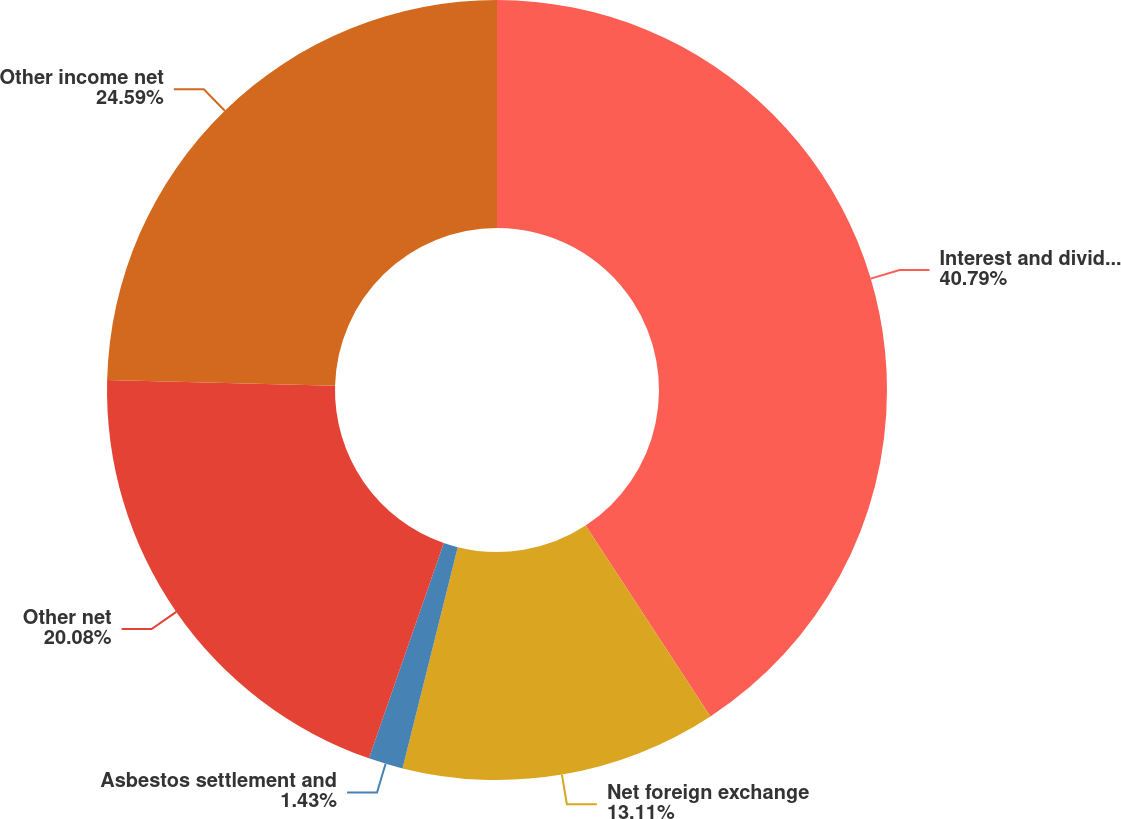<chart> <loc_0><loc_0><loc_500><loc_500><pie_chart><fcel>Interest and dividend income<fcel>Net foreign exchange<fcel>Asbestos settlement and<fcel>Other net<fcel>Other income net<nl><fcel>40.78%<fcel>13.11%<fcel>1.43%<fcel>20.08%<fcel>24.59%<nl></chart> 